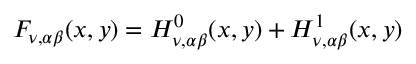Convert formula to latex. <formula><loc_0><loc_0><loc_500><loc_500>F _ { \nu , \alpha \beta } ( x , y ) = H _ { \nu , \alpha \beta } ^ { 0 } ( x , y ) + H _ { \nu , \alpha \beta } ^ { 1 } ( x , y )</formula> 